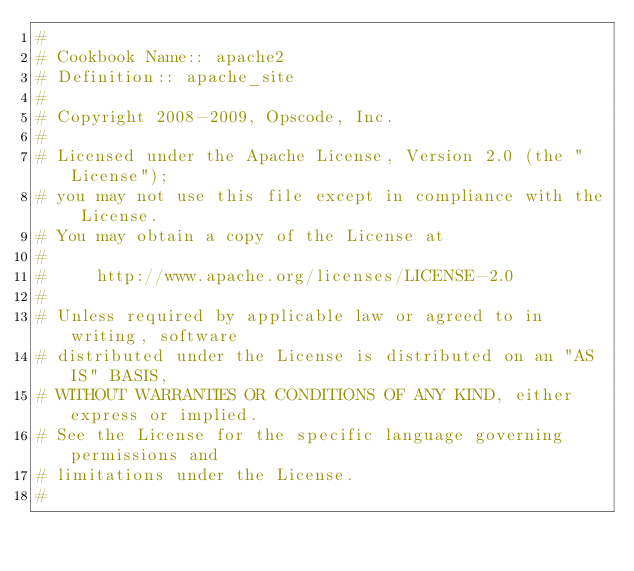<code> <loc_0><loc_0><loc_500><loc_500><_Ruby_>#
# Cookbook Name:: apache2
# Definition:: apache_site
#
# Copyright 2008-2009, Opscode, Inc.
#
# Licensed under the Apache License, Version 2.0 (the "License");
# you may not use this file except in compliance with the License.
# You may obtain a copy of the License at
#
#     http://www.apache.org/licenses/LICENSE-2.0
#
# Unless required by applicable law or agreed to in writing, software
# distributed under the License is distributed on an "AS IS" BASIS,
# WITHOUT WARRANTIES OR CONDITIONS OF ANY KIND, either express or implied.
# See the License for the specific language governing permissions and
# limitations under the License.
#
</code> 